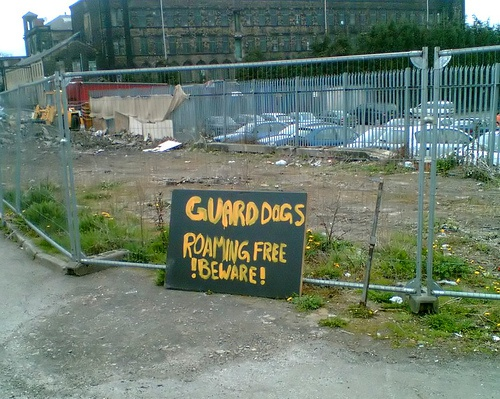Describe the objects in this image and their specific colors. I can see car in white, gray, and lightblue tones, car in white, gray, blue, and darkgray tones, car in white, gray, lightblue, and darkgray tones, car in white, gray, and lightblue tones, and car in white, gray, and darkgray tones in this image. 